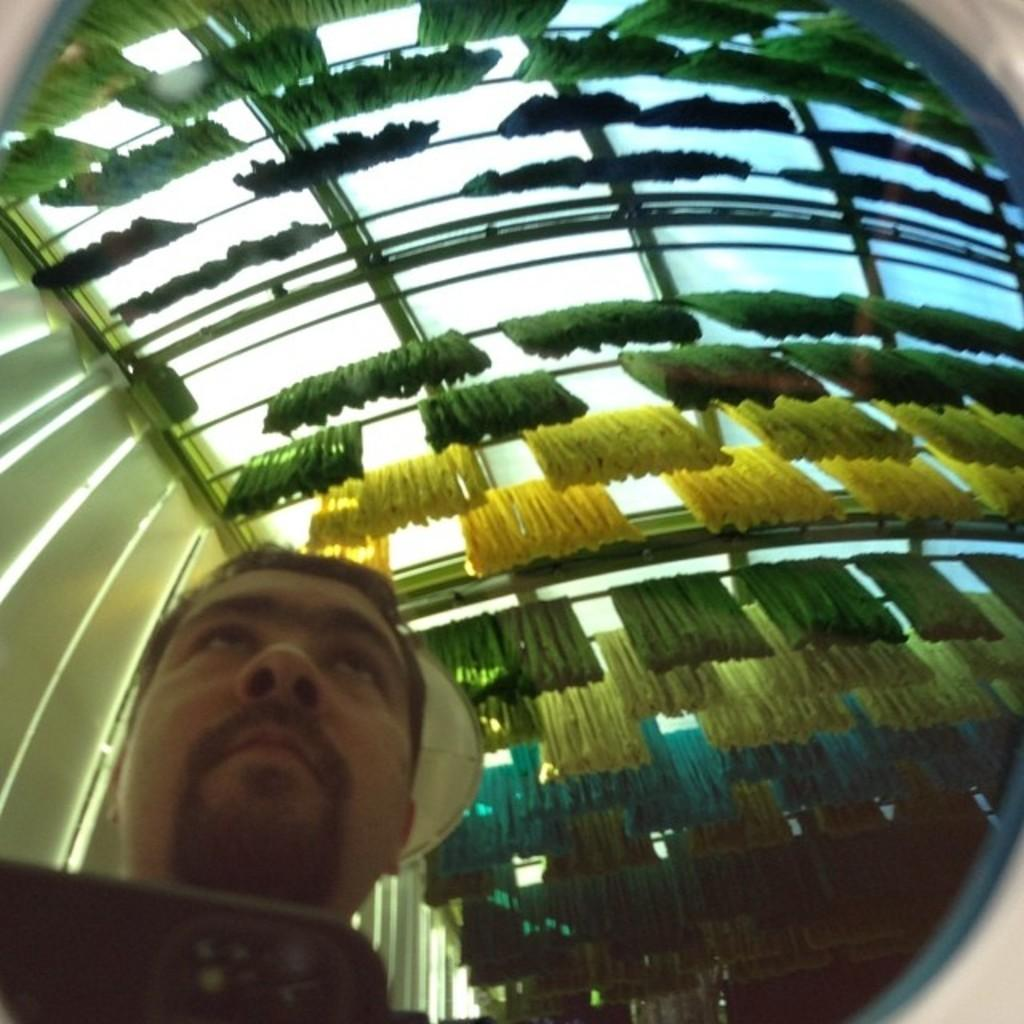Who is present in the image? There is a man in the image. What is hanging from rods above the man? Objects are hanging from rods above the man. What is beside the man in the image? There is a wall beside the man. What can be seen at the top of the image? The sky is visible at the top of the image. What type of drink is the man holding in the image? There is no drink visible in the image; the man is not holding anything. 